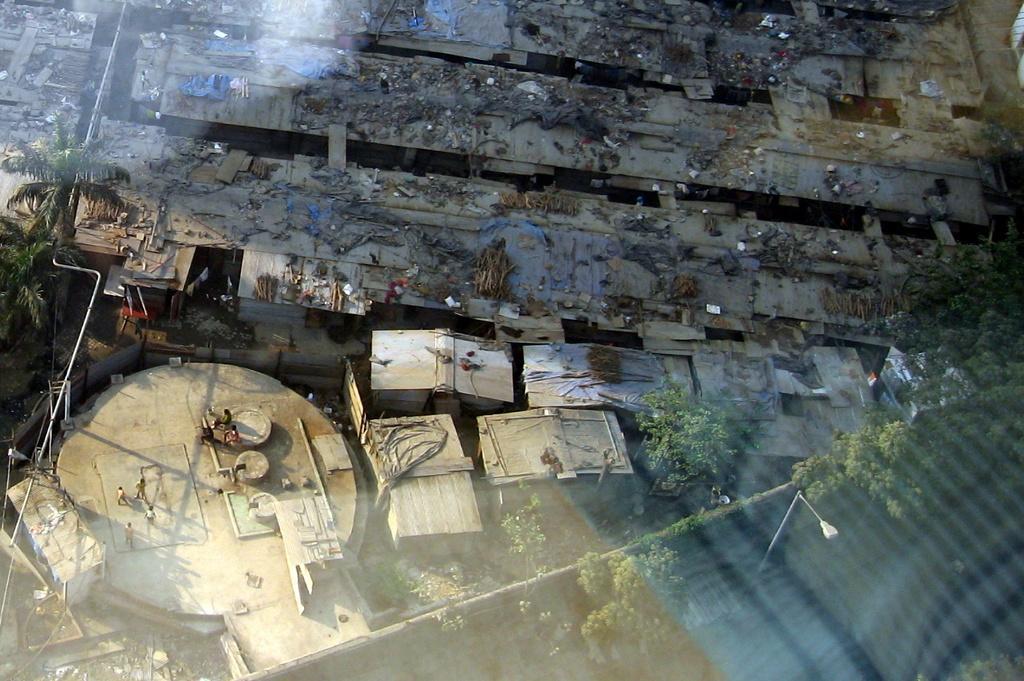In one or two sentences, can you explain what this image depicts? In this image I can see houses, trees, creepers, light poles and a group of people on the ground. This image is taken may be during a day. 